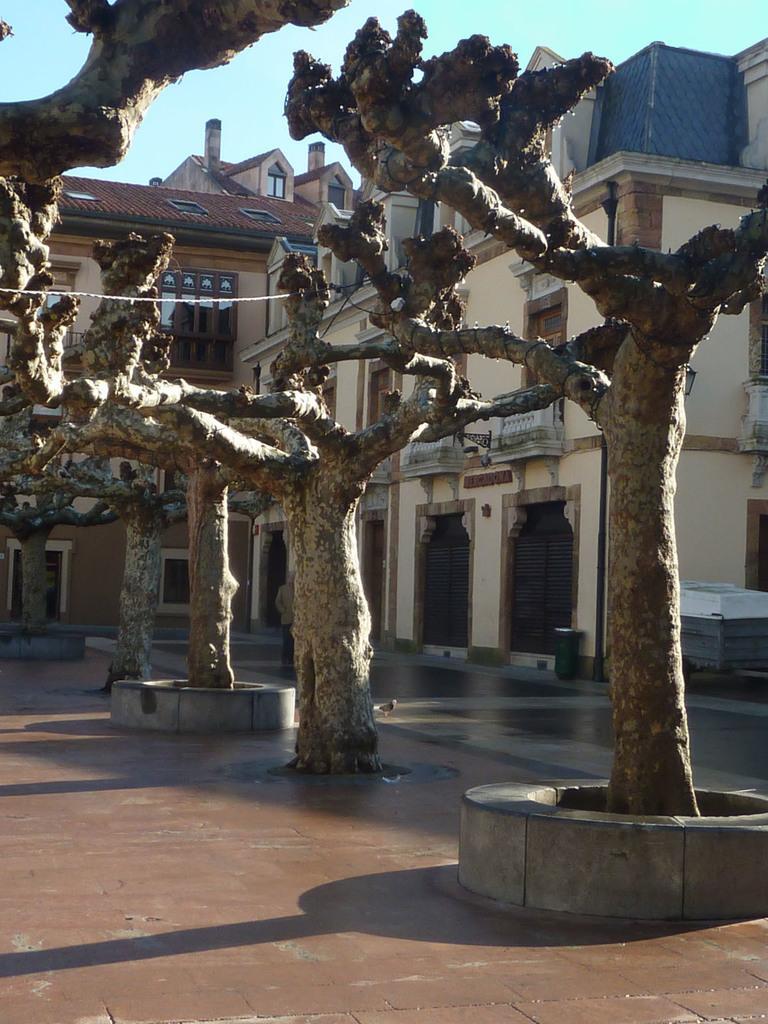Please provide a concise description of this image. In this picture we can see trees on the path and behind the trees there are buildings and a sky. 